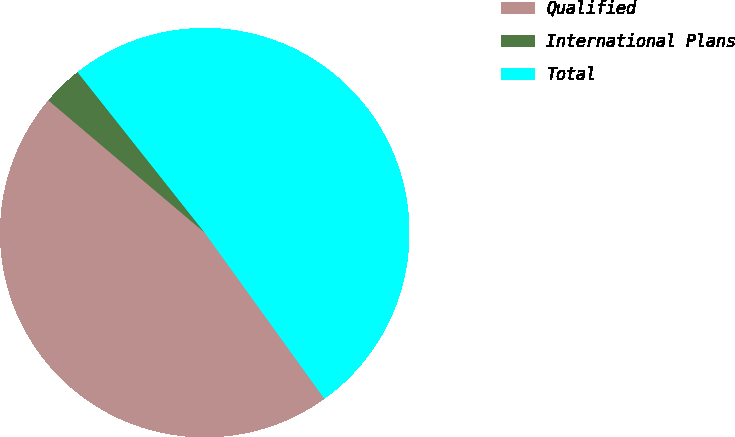Convert chart to OTSL. <chart><loc_0><loc_0><loc_500><loc_500><pie_chart><fcel>Qualified<fcel>International Plans<fcel>Total<nl><fcel>46.12%<fcel>3.16%<fcel>50.73%<nl></chart> 